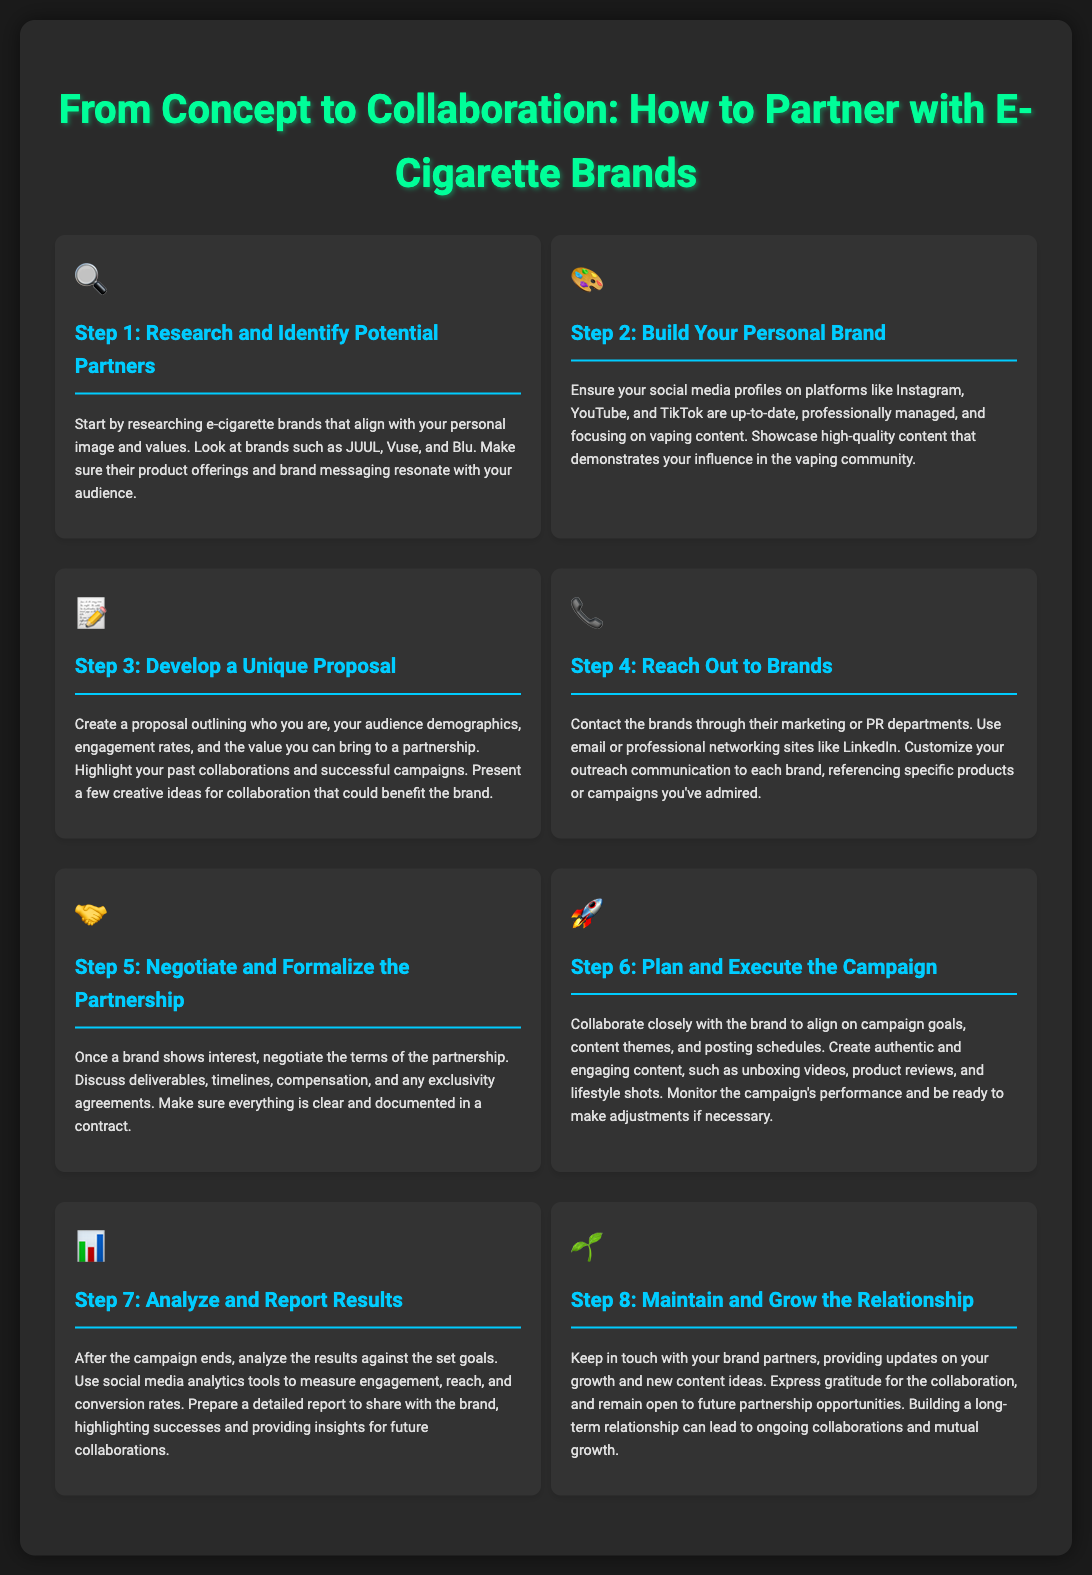What is the first step to partner with e-cigarette brands? The first step outlined in the infographic is to research e-cigarette brands that align with your personal image and values.
Answer: Research and Identify Potential Partners What icon represents Step 2? The icon associated with Step 2 in the document is a palette, symbolizing creativity and branding.
Answer: 🎨 How many steps are there in the process? The document outlines a total of eight distinct steps in partnering with e-cigarette brands, each focusing on different aspects of the collaboration process.
Answer: 8 What is emphasized in Step 3? Step 3 emphasizes the importance of developing a unique proposal that highlights your audience, engagement rates, and potential value to the partnership.
Answer: Develop a Unique Proposal What should you do in Step 4? In Step 4, you are advised to contact the brands through their marketing or PR departments, using email or professional networking sites.
Answer: Reach Out to Brands What is one type of content suggested for the campaign in Step 6? The document suggests creating unboxing videos as one type of authentic and engaging content for the campaign.
Answer: Unboxing videos What is the purpose of analyzing results in Step 7? Step 7 highlights the need to analyze campaign results to measure engagement, reach, and conversion rates and prepare a report for the brand.
Answer: Analyze and Report Results What is the goal of Step 8? The goal of Step 8 is to maintain and grow the relationship with brand partners for ongoing collaborations and mutual growth.
Answer: Maintain and Grow the Relationship 